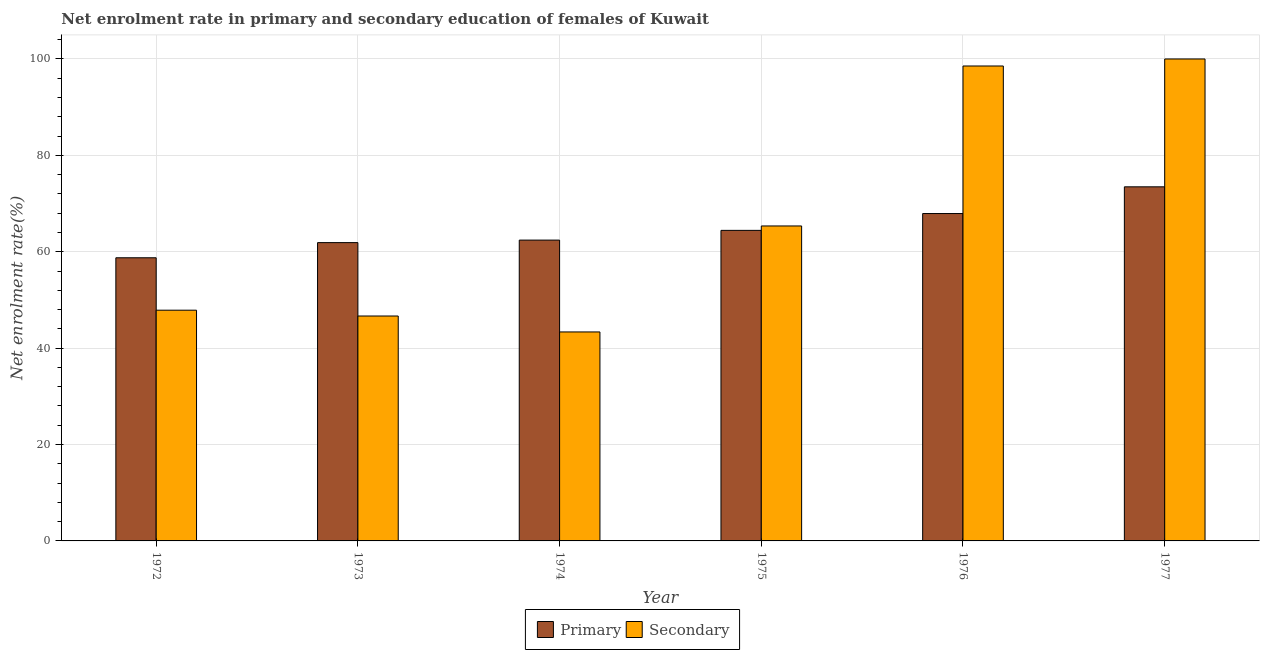How many different coloured bars are there?
Keep it short and to the point. 2. How many groups of bars are there?
Ensure brevity in your answer.  6. How many bars are there on the 1st tick from the left?
Provide a short and direct response. 2. What is the label of the 5th group of bars from the left?
Offer a very short reply. 1976. In how many cases, is the number of bars for a given year not equal to the number of legend labels?
Keep it short and to the point. 0. What is the enrollment rate in primary education in 1975?
Your response must be concise. 64.44. Across all years, what is the maximum enrollment rate in primary education?
Your answer should be very brief. 73.47. Across all years, what is the minimum enrollment rate in primary education?
Provide a short and direct response. 58.75. In which year was the enrollment rate in secondary education maximum?
Offer a very short reply. 1977. In which year was the enrollment rate in primary education minimum?
Your answer should be compact. 1972. What is the total enrollment rate in primary education in the graph?
Your response must be concise. 388.9. What is the difference between the enrollment rate in secondary education in 1976 and that in 1977?
Provide a succinct answer. -1.46. What is the difference between the enrollment rate in primary education in 1975 and the enrollment rate in secondary education in 1977?
Provide a succinct answer. -9.03. What is the average enrollment rate in secondary education per year?
Your answer should be compact. 66.97. In the year 1975, what is the difference between the enrollment rate in secondary education and enrollment rate in primary education?
Provide a succinct answer. 0. In how many years, is the enrollment rate in secondary education greater than 80 %?
Offer a terse response. 2. What is the ratio of the enrollment rate in secondary education in 1972 to that in 1974?
Your answer should be very brief. 1.1. Is the enrollment rate in primary education in 1972 less than that in 1973?
Give a very brief answer. Yes. Is the difference between the enrollment rate in primary education in 1974 and 1976 greater than the difference between the enrollment rate in secondary education in 1974 and 1976?
Your response must be concise. No. What is the difference between the highest and the second highest enrollment rate in primary education?
Make the answer very short. 5.54. What is the difference between the highest and the lowest enrollment rate in primary education?
Your response must be concise. 14.72. Is the sum of the enrollment rate in primary education in 1975 and 1977 greater than the maximum enrollment rate in secondary education across all years?
Provide a short and direct response. Yes. What does the 1st bar from the left in 1974 represents?
Keep it short and to the point. Primary. What does the 2nd bar from the right in 1974 represents?
Your answer should be compact. Primary. How many years are there in the graph?
Offer a very short reply. 6. What is the difference between two consecutive major ticks on the Y-axis?
Your response must be concise. 20. Are the values on the major ticks of Y-axis written in scientific E-notation?
Your answer should be compact. No. Does the graph contain any zero values?
Ensure brevity in your answer.  No. How are the legend labels stacked?
Ensure brevity in your answer.  Horizontal. What is the title of the graph?
Your answer should be compact. Net enrolment rate in primary and secondary education of females of Kuwait. What is the label or title of the Y-axis?
Your answer should be compact. Net enrolment rate(%). What is the Net enrolment rate(%) of Primary in 1972?
Provide a short and direct response. 58.75. What is the Net enrolment rate(%) in Secondary in 1972?
Your answer should be very brief. 47.87. What is the Net enrolment rate(%) of Primary in 1973?
Make the answer very short. 61.9. What is the Net enrolment rate(%) of Secondary in 1973?
Ensure brevity in your answer.  46.67. What is the Net enrolment rate(%) of Primary in 1974?
Your response must be concise. 62.42. What is the Net enrolment rate(%) in Secondary in 1974?
Provide a short and direct response. 43.36. What is the Net enrolment rate(%) of Primary in 1975?
Your answer should be compact. 64.44. What is the Net enrolment rate(%) of Secondary in 1975?
Your answer should be compact. 65.35. What is the Net enrolment rate(%) of Primary in 1976?
Your response must be concise. 67.93. What is the Net enrolment rate(%) of Secondary in 1976?
Ensure brevity in your answer.  98.54. What is the Net enrolment rate(%) of Primary in 1977?
Ensure brevity in your answer.  73.47. Across all years, what is the maximum Net enrolment rate(%) in Primary?
Give a very brief answer. 73.47. Across all years, what is the maximum Net enrolment rate(%) in Secondary?
Keep it short and to the point. 100. Across all years, what is the minimum Net enrolment rate(%) of Primary?
Provide a succinct answer. 58.75. Across all years, what is the minimum Net enrolment rate(%) of Secondary?
Make the answer very short. 43.36. What is the total Net enrolment rate(%) in Primary in the graph?
Provide a short and direct response. 388.9. What is the total Net enrolment rate(%) of Secondary in the graph?
Keep it short and to the point. 401.8. What is the difference between the Net enrolment rate(%) of Primary in 1972 and that in 1973?
Ensure brevity in your answer.  -3.15. What is the difference between the Net enrolment rate(%) of Secondary in 1972 and that in 1973?
Offer a very short reply. 1.21. What is the difference between the Net enrolment rate(%) of Primary in 1972 and that in 1974?
Provide a succinct answer. -3.67. What is the difference between the Net enrolment rate(%) in Secondary in 1972 and that in 1974?
Give a very brief answer. 4.51. What is the difference between the Net enrolment rate(%) of Primary in 1972 and that in 1975?
Give a very brief answer. -5.69. What is the difference between the Net enrolment rate(%) in Secondary in 1972 and that in 1975?
Give a very brief answer. -17.48. What is the difference between the Net enrolment rate(%) of Primary in 1972 and that in 1976?
Make the answer very short. -9.18. What is the difference between the Net enrolment rate(%) in Secondary in 1972 and that in 1976?
Provide a short and direct response. -50.67. What is the difference between the Net enrolment rate(%) in Primary in 1972 and that in 1977?
Provide a short and direct response. -14.72. What is the difference between the Net enrolment rate(%) in Secondary in 1972 and that in 1977?
Your answer should be very brief. -52.13. What is the difference between the Net enrolment rate(%) in Primary in 1973 and that in 1974?
Give a very brief answer. -0.52. What is the difference between the Net enrolment rate(%) in Secondary in 1973 and that in 1974?
Give a very brief answer. 3.31. What is the difference between the Net enrolment rate(%) of Primary in 1973 and that in 1975?
Provide a succinct answer. -2.54. What is the difference between the Net enrolment rate(%) in Secondary in 1973 and that in 1975?
Keep it short and to the point. -18.69. What is the difference between the Net enrolment rate(%) of Primary in 1973 and that in 1976?
Offer a very short reply. -6.03. What is the difference between the Net enrolment rate(%) of Secondary in 1973 and that in 1976?
Offer a terse response. -51.88. What is the difference between the Net enrolment rate(%) in Primary in 1973 and that in 1977?
Give a very brief answer. -11.58. What is the difference between the Net enrolment rate(%) in Secondary in 1973 and that in 1977?
Keep it short and to the point. -53.33. What is the difference between the Net enrolment rate(%) in Primary in 1974 and that in 1975?
Offer a very short reply. -2.02. What is the difference between the Net enrolment rate(%) in Secondary in 1974 and that in 1975?
Make the answer very short. -21.99. What is the difference between the Net enrolment rate(%) of Primary in 1974 and that in 1976?
Provide a short and direct response. -5.51. What is the difference between the Net enrolment rate(%) of Secondary in 1974 and that in 1976?
Offer a very short reply. -55.18. What is the difference between the Net enrolment rate(%) of Primary in 1974 and that in 1977?
Provide a short and direct response. -11.06. What is the difference between the Net enrolment rate(%) in Secondary in 1974 and that in 1977?
Offer a terse response. -56.64. What is the difference between the Net enrolment rate(%) of Primary in 1975 and that in 1976?
Your response must be concise. -3.49. What is the difference between the Net enrolment rate(%) in Secondary in 1975 and that in 1976?
Your answer should be very brief. -33.19. What is the difference between the Net enrolment rate(%) of Primary in 1975 and that in 1977?
Ensure brevity in your answer.  -9.03. What is the difference between the Net enrolment rate(%) in Secondary in 1975 and that in 1977?
Give a very brief answer. -34.65. What is the difference between the Net enrolment rate(%) of Primary in 1976 and that in 1977?
Keep it short and to the point. -5.54. What is the difference between the Net enrolment rate(%) of Secondary in 1976 and that in 1977?
Your answer should be compact. -1.46. What is the difference between the Net enrolment rate(%) in Primary in 1972 and the Net enrolment rate(%) in Secondary in 1973?
Provide a succinct answer. 12.08. What is the difference between the Net enrolment rate(%) of Primary in 1972 and the Net enrolment rate(%) of Secondary in 1974?
Give a very brief answer. 15.39. What is the difference between the Net enrolment rate(%) in Primary in 1972 and the Net enrolment rate(%) in Secondary in 1975?
Give a very brief answer. -6.6. What is the difference between the Net enrolment rate(%) in Primary in 1972 and the Net enrolment rate(%) in Secondary in 1976?
Provide a succinct answer. -39.79. What is the difference between the Net enrolment rate(%) in Primary in 1972 and the Net enrolment rate(%) in Secondary in 1977?
Your answer should be very brief. -41.25. What is the difference between the Net enrolment rate(%) in Primary in 1973 and the Net enrolment rate(%) in Secondary in 1974?
Offer a very short reply. 18.53. What is the difference between the Net enrolment rate(%) in Primary in 1973 and the Net enrolment rate(%) in Secondary in 1975?
Keep it short and to the point. -3.46. What is the difference between the Net enrolment rate(%) in Primary in 1973 and the Net enrolment rate(%) in Secondary in 1976?
Give a very brief answer. -36.65. What is the difference between the Net enrolment rate(%) of Primary in 1973 and the Net enrolment rate(%) of Secondary in 1977?
Ensure brevity in your answer.  -38.1. What is the difference between the Net enrolment rate(%) of Primary in 1974 and the Net enrolment rate(%) of Secondary in 1975?
Keep it short and to the point. -2.94. What is the difference between the Net enrolment rate(%) in Primary in 1974 and the Net enrolment rate(%) in Secondary in 1976?
Offer a very short reply. -36.13. What is the difference between the Net enrolment rate(%) in Primary in 1974 and the Net enrolment rate(%) in Secondary in 1977?
Provide a short and direct response. -37.58. What is the difference between the Net enrolment rate(%) of Primary in 1975 and the Net enrolment rate(%) of Secondary in 1976?
Offer a terse response. -34.11. What is the difference between the Net enrolment rate(%) of Primary in 1975 and the Net enrolment rate(%) of Secondary in 1977?
Ensure brevity in your answer.  -35.56. What is the difference between the Net enrolment rate(%) in Primary in 1976 and the Net enrolment rate(%) in Secondary in 1977?
Offer a very short reply. -32.07. What is the average Net enrolment rate(%) of Primary per year?
Make the answer very short. 64.82. What is the average Net enrolment rate(%) in Secondary per year?
Give a very brief answer. 66.97. In the year 1972, what is the difference between the Net enrolment rate(%) in Primary and Net enrolment rate(%) in Secondary?
Keep it short and to the point. 10.88. In the year 1973, what is the difference between the Net enrolment rate(%) in Primary and Net enrolment rate(%) in Secondary?
Your answer should be very brief. 15.23. In the year 1974, what is the difference between the Net enrolment rate(%) of Primary and Net enrolment rate(%) of Secondary?
Your answer should be compact. 19.06. In the year 1975, what is the difference between the Net enrolment rate(%) of Primary and Net enrolment rate(%) of Secondary?
Your response must be concise. -0.92. In the year 1976, what is the difference between the Net enrolment rate(%) of Primary and Net enrolment rate(%) of Secondary?
Your answer should be very brief. -30.61. In the year 1977, what is the difference between the Net enrolment rate(%) of Primary and Net enrolment rate(%) of Secondary?
Provide a succinct answer. -26.53. What is the ratio of the Net enrolment rate(%) in Primary in 1972 to that in 1973?
Ensure brevity in your answer.  0.95. What is the ratio of the Net enrolment rate(%) of Secondary in 1972 to that in 1973?
Ensure brevity in your answer.  1.03. What is the ratio of the Net enrolment rate(%) of Primary in 1972 to that in 1974?
Offer a very short reply. 0.94. What is the ratio of the Net enrolment rate(%) in Secondary in 1972 to that in 1974?
Make the answer very short. 1.1. What is the ratio of the Net enrolment rate(%) in Primary in 1972 to that in 1975?
Give a very brief answer. 0.91. What is the ratio of the Net enrolment rate(%) in Secondary in 1972 to that in 1975?
Provide a short and direct response. 0.73. What is the ratio of the Net enrolment rate(%) of Primary in 1972 to that in 1976?
Your answer should be very brief. 0.86. What is the ratio of the Net enrolment rate(%) of Secondary in 1972 to that in 1976?
Provide a succinct answer. 0.49. What is the ratio of the Net enrolment rate(%) in Primary in 1972 to that in 1977?
Keep it short and to the point. 0.8. What is the ratio of the Net enrolment rate(%) of Secondary in 1972 to that in 1977?
Provide a short and direct response. 0.48. What is the ratio of the Net enrolment rate(%) in Primary in 1973 to that in 1974?
Ensure brevity in your answer.  0.99. What is the ratio of the Net enrolment rate(%) of Secondary in 1973 to that in 1974?
Provide a short and direct response. 1.08. What is the ratio of the Net enrolment rate(%) of Primary in 1973 to that in 1975?
Ensure brevity in your answer.  0.96. What is the ratio of the Net enrolment rate(%) in Secondary in 1973 to that in 1975?
Your answer should be very brief. 0.71. What is the ratio of the Net enrolment rate(%) of Primary in 1973 to that in 1976?
Offer a very short reply. 0.91. What is the ratio of the Net enrolment rate(%) of Secondary in 1973 to that in 1976?
Offer a very short reply. 0.47. What is the ratio of the Net enrolment rate(%) in Primary in 1973 to that in 1977?
Your answer should be very brief. 0.84. What is the ratio of the Net enrolment rate(%) of Secondary in 1973 to that in 1977?
Your response must be concise. 0.47. What is the ratio of the Net enrolment rate(%) in Primary in 1974 to that in 1975?
Your answer should be very brief. 0.97. What is the ratio of the Net enrolment rate(%) in Secondary in 1974 to that in 1975?
Your response must be concise. 0.66. What is the ratio of the Net enrolment rate(%) in Primary in 1974 to that in 1976?
Your response must be concise. 0.92. What is the ratio of the Net enrolment rate(%) of Secondary in 1974 to that in 1976?
Your response must be concise. 0.44. What is the ratio of the Net enrolment rate(%) of Primary in 1974 to that in 1977?
Provide a short and direct response. 0.85. What is the ratio of the Net enrolment rate(%) in Secondary in 1974 to that in 1977?
Provide a short and direct response. 0.43. What is the ratio of the Net enrolment rate(%) of Primary in 1975 to that in 1976?
Your answer should be very brief. 0.95. What is the ratio of the Net enrolment rate(%) in Secondary in 1975 to that in 1976?
Provide a short and direct response. 0.66. What is the ratio of the Net enrolment rate(%) of Primary in 1975 to that in 1977?
Your response must be concise. 0.88. What is the ratio of the Net enrolment rate(%) of Secondary in 1975 to that in 1977?
Offer a very short reply. 0.65. What is the ratio of the Net enrolment rate(%) of Primary in 1976 to that in 1977?
Offer a very short reply. 0.92. What is the ratio of the Net enrolment rate(%) in Secondary in 1976 to that in 1977?
Your answer should be very brief. 0.99. What is the difference between the highest and the second highest Net enrolment rate(%) of Primary?
Your answer should be compact. 5.54. What is the difference between the highest and the second highest Net enrolment rate(%) in Secondary?
Offer a terse response. 1.46. What is the difference between the highest and the lowest Net enrolment rate(%) in Primary?
Provide a succinct answer. 14.72. What is the difference between the highest and the lowest Net enrolment rate(%) of Secondary?
Offer a very short reply. 56.64. 